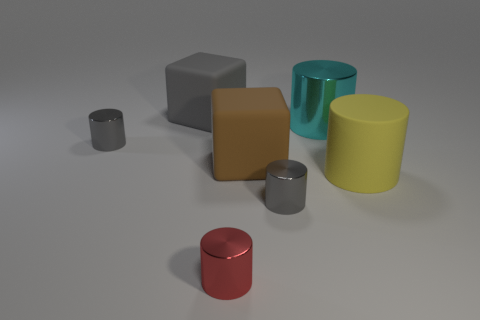What color is the other cylinder that is the same size as the yellow matte cylinder?
Make the answer very short. Cyan. Are there an equal number of large metallic things left of the brown object and objects behind the large cyan metallic cylinder?
Your response must be concise. No. There is a large rubber object right of the cyan cylinder; does it have the same shape as the big matte object that is left of the red cylinder?
Provide a short and direct response. No. The big matte thing that is the same shape as the cyan shiny object is what color?
Offer a very short reply. Yellow. There is a cyan cylinder; is its size the same as the red metallic object to the left of the big cyan thing?
Provide a succinct answer. No. How many red things are either tiny objects or big matte cylinders?
Offer a terse response. 1. How many tiny green shiny cylinders are there?
Keep it short and to the point. 0. There is a gray shiny object that is in front of the yellow rubber object; what is its size?
Your response must be concise. Small. Is the cyan thing the same size as the red metal thing?
Your answer should be very brief. No. What number of objects are big gray rubber blocks or large gray blocks to the left of the big yellow cylinder?
Give a very brief answer. 1. 